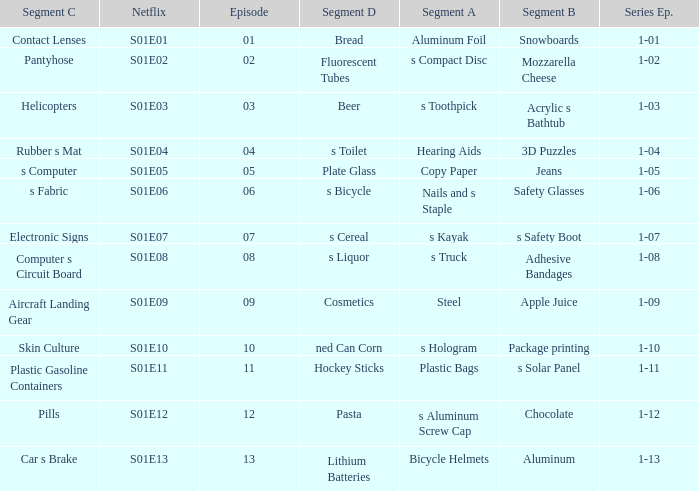What is the series episode number with a segment of D, and having fluorescent tubes? 1-02. 